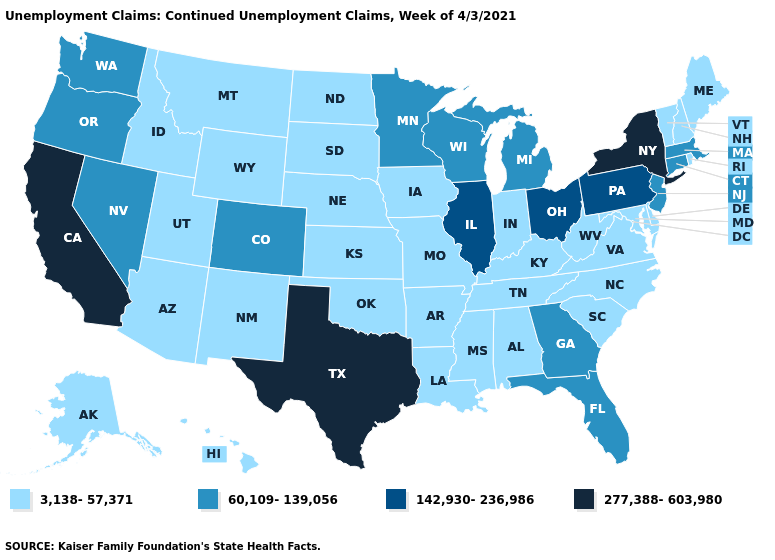Does the map have missing data?
Give a very brief answer. No. Among the states that border Arkansas , does Texas have the highest value?
Be succinct. Yes. Name the states that have a value in the range 60,109-139,056?
Keep it brief. Colorado, Connecticut, Florida, Georgia, Massachusetts, Michigan, Minnesota, Nevada, New Jersey, Oregon, Washington, Wisconsin. What is the value of Delaware?
Short answer required. 3,138-57,371. What is the highest value in states that border West Virginia?
Concise answer only. 142,930-236,986. What is the value of Idaho?
Give a very brief answer. 3,138-57,371. What is the highest value in states that border New York?
Answer briefly. 142,930-236,986. Name the states that have a value in the range 142,930-236,986?
Short answer required. Illinois, Ohio, Pennsylvania. Name the states that have a value in the range 142,930-236,986?
Write a very short answer. Illinois, Ohio, Pennsylvania. Which states have the lowest value in the USA?
Give a very brief answer. Alabama, Alaska, Arizona, Arkansas, Delaware, Hawaii, Idaho, Indiana, Iowa, Kansas, Kentucky, Louisiana, Maine, Maryland, Mississippi, Missouri, Montana, Nebraska, New Hampshire, New Mexico, North Carolina, North Dakota, Oklahoma, Rhode Island, South Carolina, South Dakota, Tennessee, Utah, Vermont, Virginia, West Virginia, Wyoming. Which states have the highest value in the USA?
Concise answer only. California, New York, Texas. Name the states that have a value in the range 3,138-57,371?
Answer briefly. Alabama, Alaska, Arizona, Arkansas, Delaware, Hawaii, Idaho, Indiana, Iowa, Kansas, Kentucky, Louisiana, Maine, Maryland, Mississippi, Missouri, Montana, Nebraska, New Hampshire, New Mexico, North Carolina, North Dakota, Oklahoma, Rhode Island, South Carolina, South Dakota, Tennessee, Utah, Vermont, Virginia, West Virginia, Wyoming. What is the value of Montana?
Be succinct. 3,138-57,371. What is the highest value in the Northeast ?
Write a very short answer. 277,388-603,980. Name the states that have a value in the range 142,930-236,986?
Answer briefly. Illinois, Ohio, Pennsylvania. 